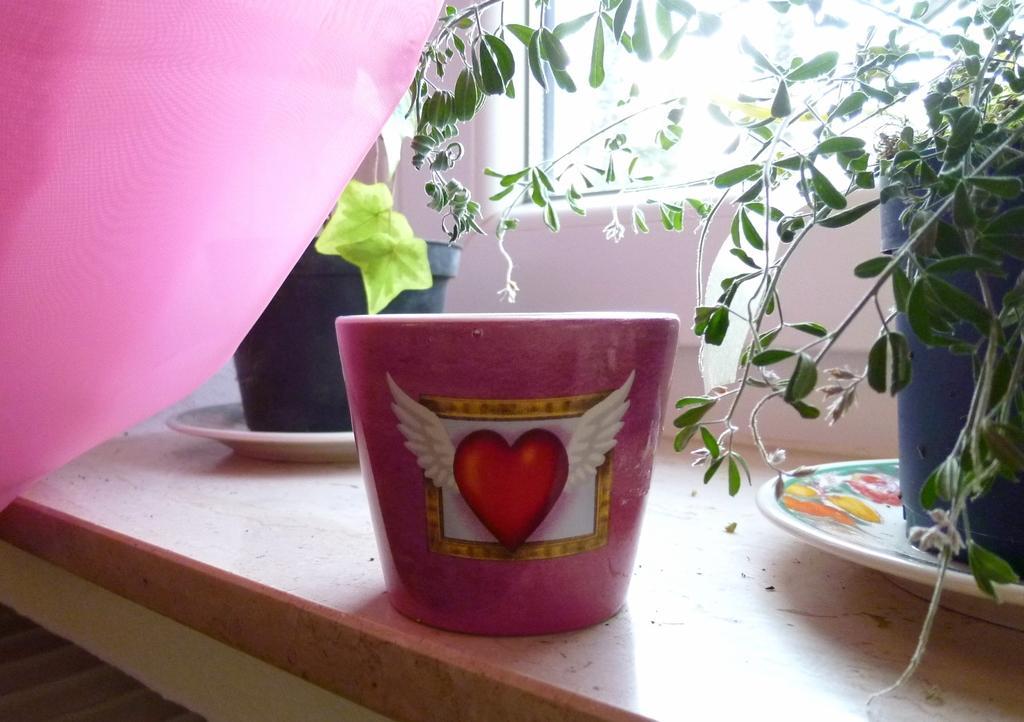Describe this image in one or two sentences. In this picture, we see a pink color with heart shaped symbol on it, is placed on the table. Beside that, we see two plates on which flower pots are placed. These flower pots are placed on the table. Behind that, we see a white wall and a glass window. In the left top of the picture, we see a cloth in pink color. 